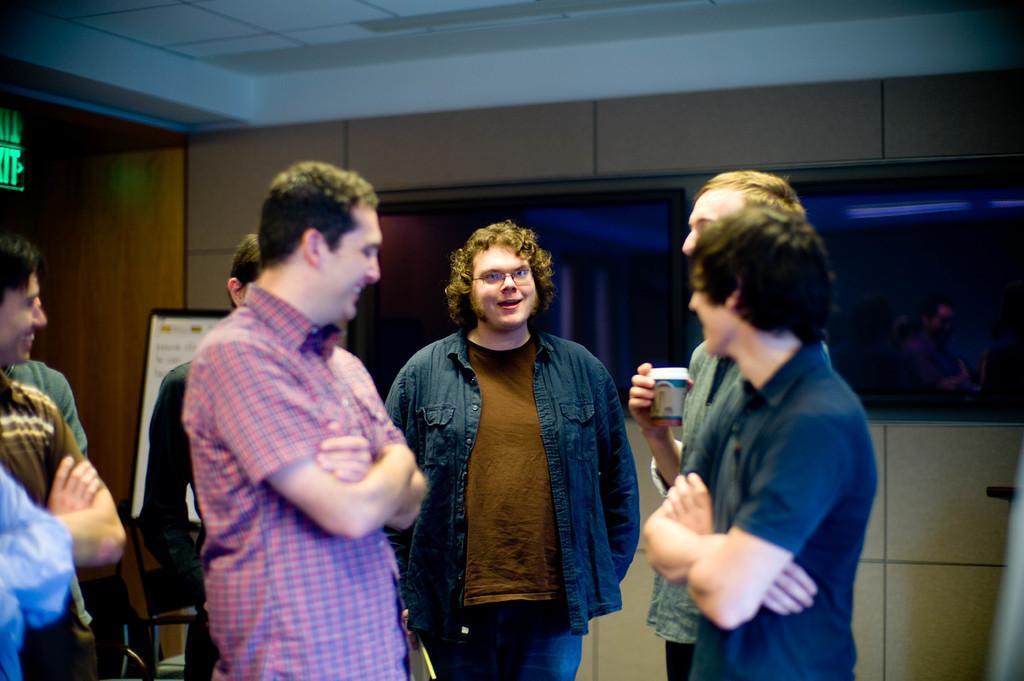Could you give a brief overview of what you see in this image? In this image there are some people who are standing and smiling, and some of them are talking and one person is holding a cup. And in the background there are two televisions on the wall, on the left side there are some boards and at the top there is ceiling. 